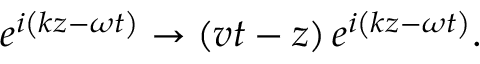<formula> <loc_0><loc_0><loc_500><loc_500>e ^ { i \left ( k z - \omega t \right ) } \rightarrow \left ( v t - z \right ) e ^ { i \left ( k z - \omega t \right ) } .</formula> 